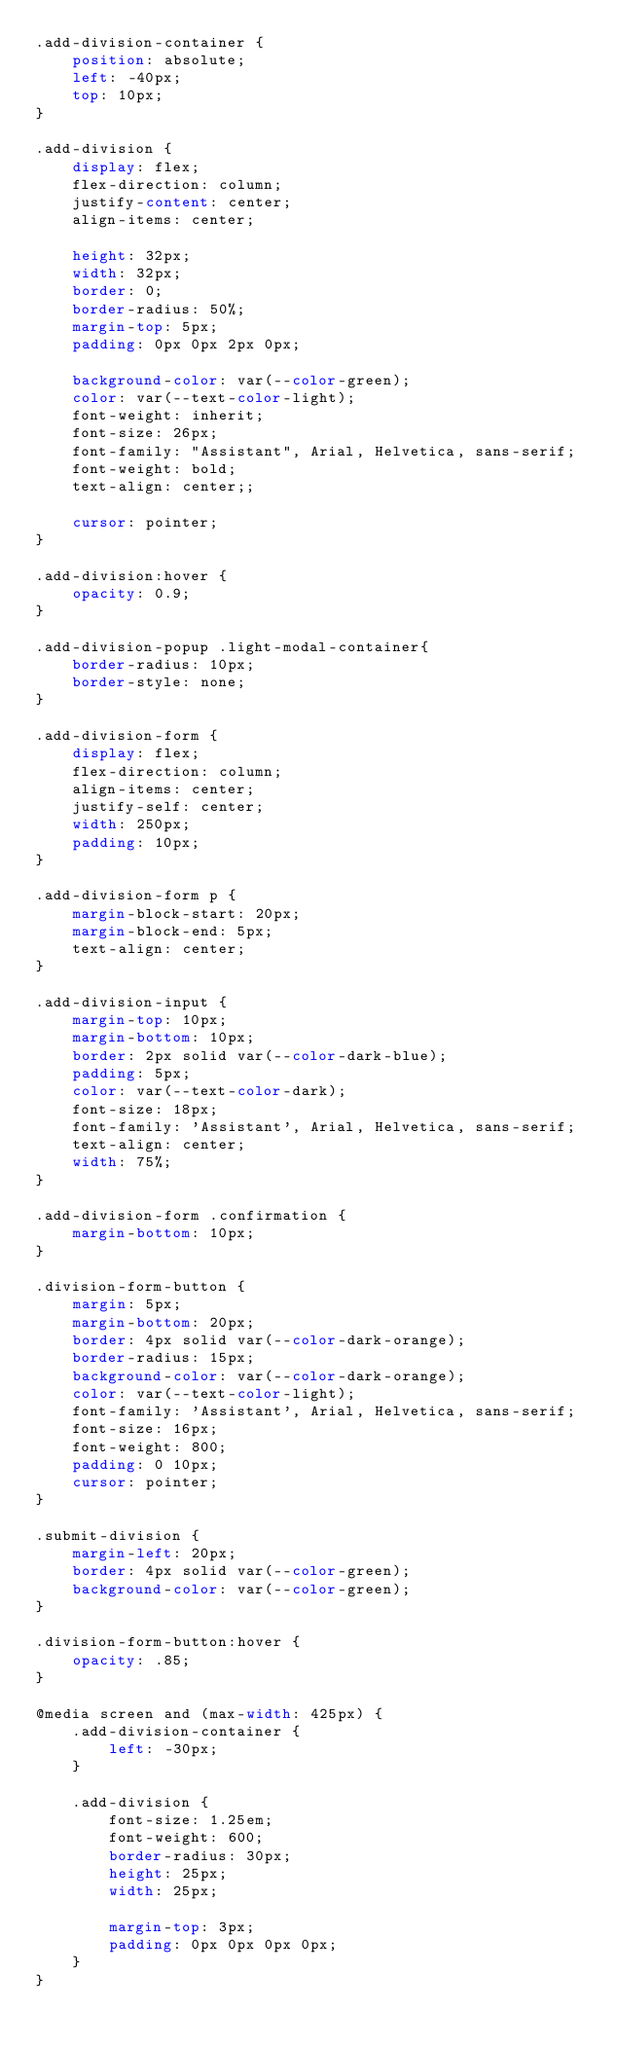Convert code to text. <code><loc_0><loc_0><loc_500><loc_500><_CSS_>.add-division-container {
    position: absolute;
    left: -40px;
    top: 10px;
}

.add-division {
    display: flex;
    flex-direction: column;
    justify-content: center;
    align-items: center;

    height: 32px;
    width: 32px;
    border: 0;
    border-radius: 50%;
    margin-top: 5px;
    padding: 0px 0px 2px 0px;

    background-color: var(--color-green);
    color: var(--text-color-light);
    font-weight: inherit;
    font-size: 26px;
    font-family: "Assistant", Arial, Helvetica, sans-serif;
    font-weight: bold;
    text-align: center;;

    cursor: pointer;
}

.add-division:hover {
    opacity: 0.9;
}

.add-division-popup .light-modal-container{  
    border-radius: 10px;
    border-style: none;
}

.add-division-form {
    display: flex;
    flex-direction: column;
    align-items: center;
    justify-self: center;
    width: 250px;
    padding: 10px;
}

.add-division-form p {
    margin-block-start: 20px;
    margin-block-end: 5px;
    text-align: center;
}

.add-division-input {
    margin-top: 10px;
    margin-bottom: 10px;
    border: 2px solid var(--color-dark-blue);
    padding: 5px;
    color: var(--text-color-dark);
    font-size: 18px;
    font-family: 'Assistant', Arial, Helvetica, sans-serif;
    text-align: center;
    width: 75%;
}

.add-division-form .confirmation {
    margin-bottom: 10px;
}

.division-form-button {
    margin: 5px;
    margin-bottom: 20px;
    border: 4px solid var(--color-dark-orange);
    border-radius: 15px;
    background-color: var(--color-dark-orange);
    color: var(--text-color-light);
    font-family: 'Assistant', Arial, Helvetica, sans-serif;
    font-size: 16px;
    font-weight: 800;
    padding: 0 10px;
    cursor: pointer;
}

.submit-division {
    margin-left: 20px;
    border: 4px solid var(--color-green);
    background-color: var(--color-green);
}

.division-form-button:hover {
    opacity: .85;
}

@media screen and (max-width: 425px) {
    .add-division-container {
        left: -30px;
    }

    .add-division {
        font-size: 1.25em;
        font-weight: 600;
        border-radius: 30px;
        height: 25px;
        width: 25px;

        margin-top: 3px;
        padding: 0px 0px 0px 0px;
    }
}</code> 